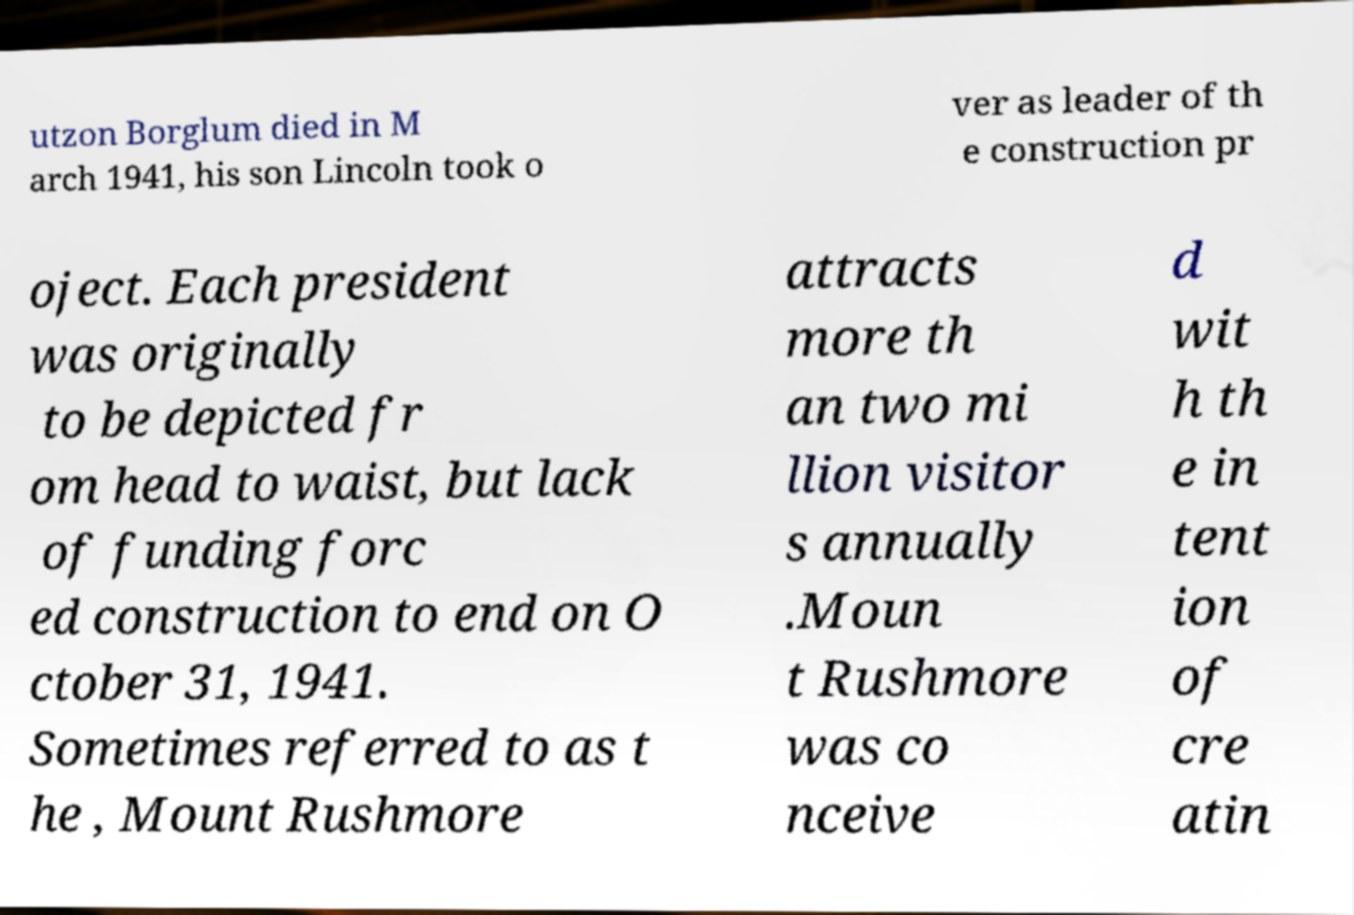What messages or text are displayed in this image? I need them in a readable, typed format. utzon Borglum died in M arch 1941, his son Lincoln took o ver as leader of th e construction pr oject. Each president was originally to be depicted fr om head to waist, but lack of funding forc ed construction to end on O ctober 31, 1941. Sometimes referred to as t he , Mount Rushmore attracts more th an two mi llion visitor s annually .Moun t Rushmore was co nceive d wit h th e in tent ion of cre atin 